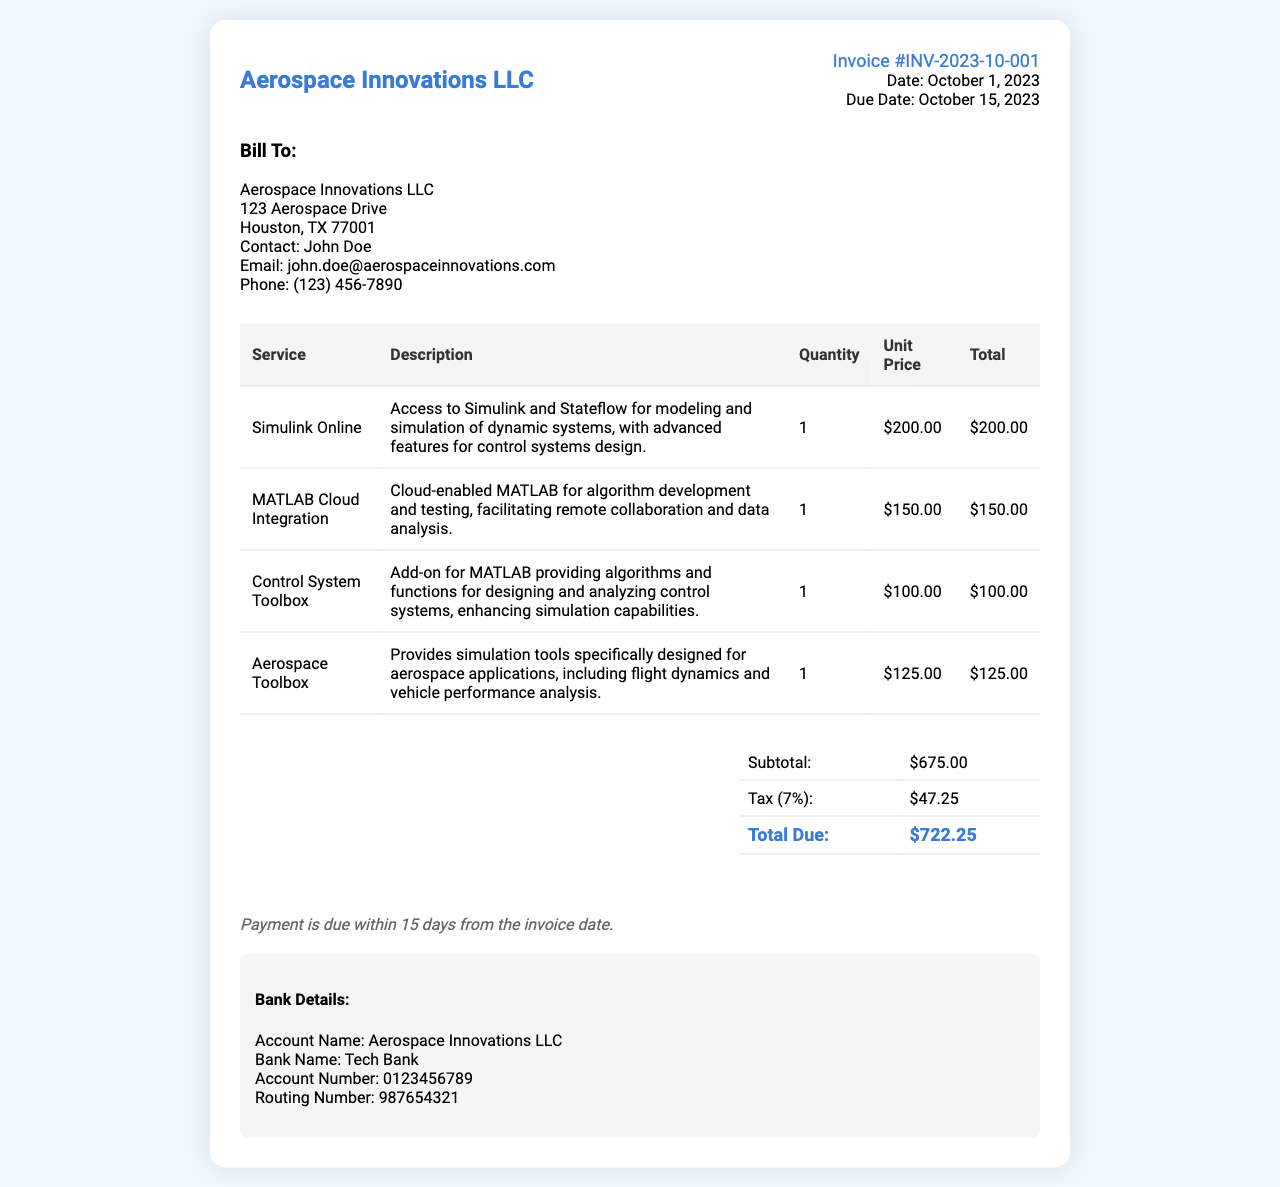what is the invoice number? The invoice number can be found in the document header and identifies this specific transaction: INV-2023-10-001.
Answer: INV-2023-10-001 what is the due date? The due date is located in the invoice details section and indicates when the payment should be made: October 15, 2023.
Answer: October 15, 2023 who is the contact person for the bill? The contact person for the billing details is mentioned in the bill-to section, which specifies John Doe as the contact.
Answer: John Doe what is the subtotal amount? The subtotal amount is calculated before tax and is explicitly stated in the total section: $675.00.
Answer: $675.00 how much is the tax charged? The tax amount is detailed in the total section reflecting a 7% tax on the subtotal: $47.25.
Answer: $47.25 what service has the highest unit price? By comparing the unit prices of all services, the highest price is for Simulink Online at $200.00.
Answer: Simulink Online what is the total due amount? The total due is the amount that must be paid after the subtotal and tax have been accounted for: $722.25.
Answer: $722.25 how many services are listed in the invoice? The document lists four different services provided, as reflected in the table.
Answer: 4 what is the bank name provided for payment? The bank name for payment is specified in the bank details section: Tech Bank.
Answer: Tech Bank 